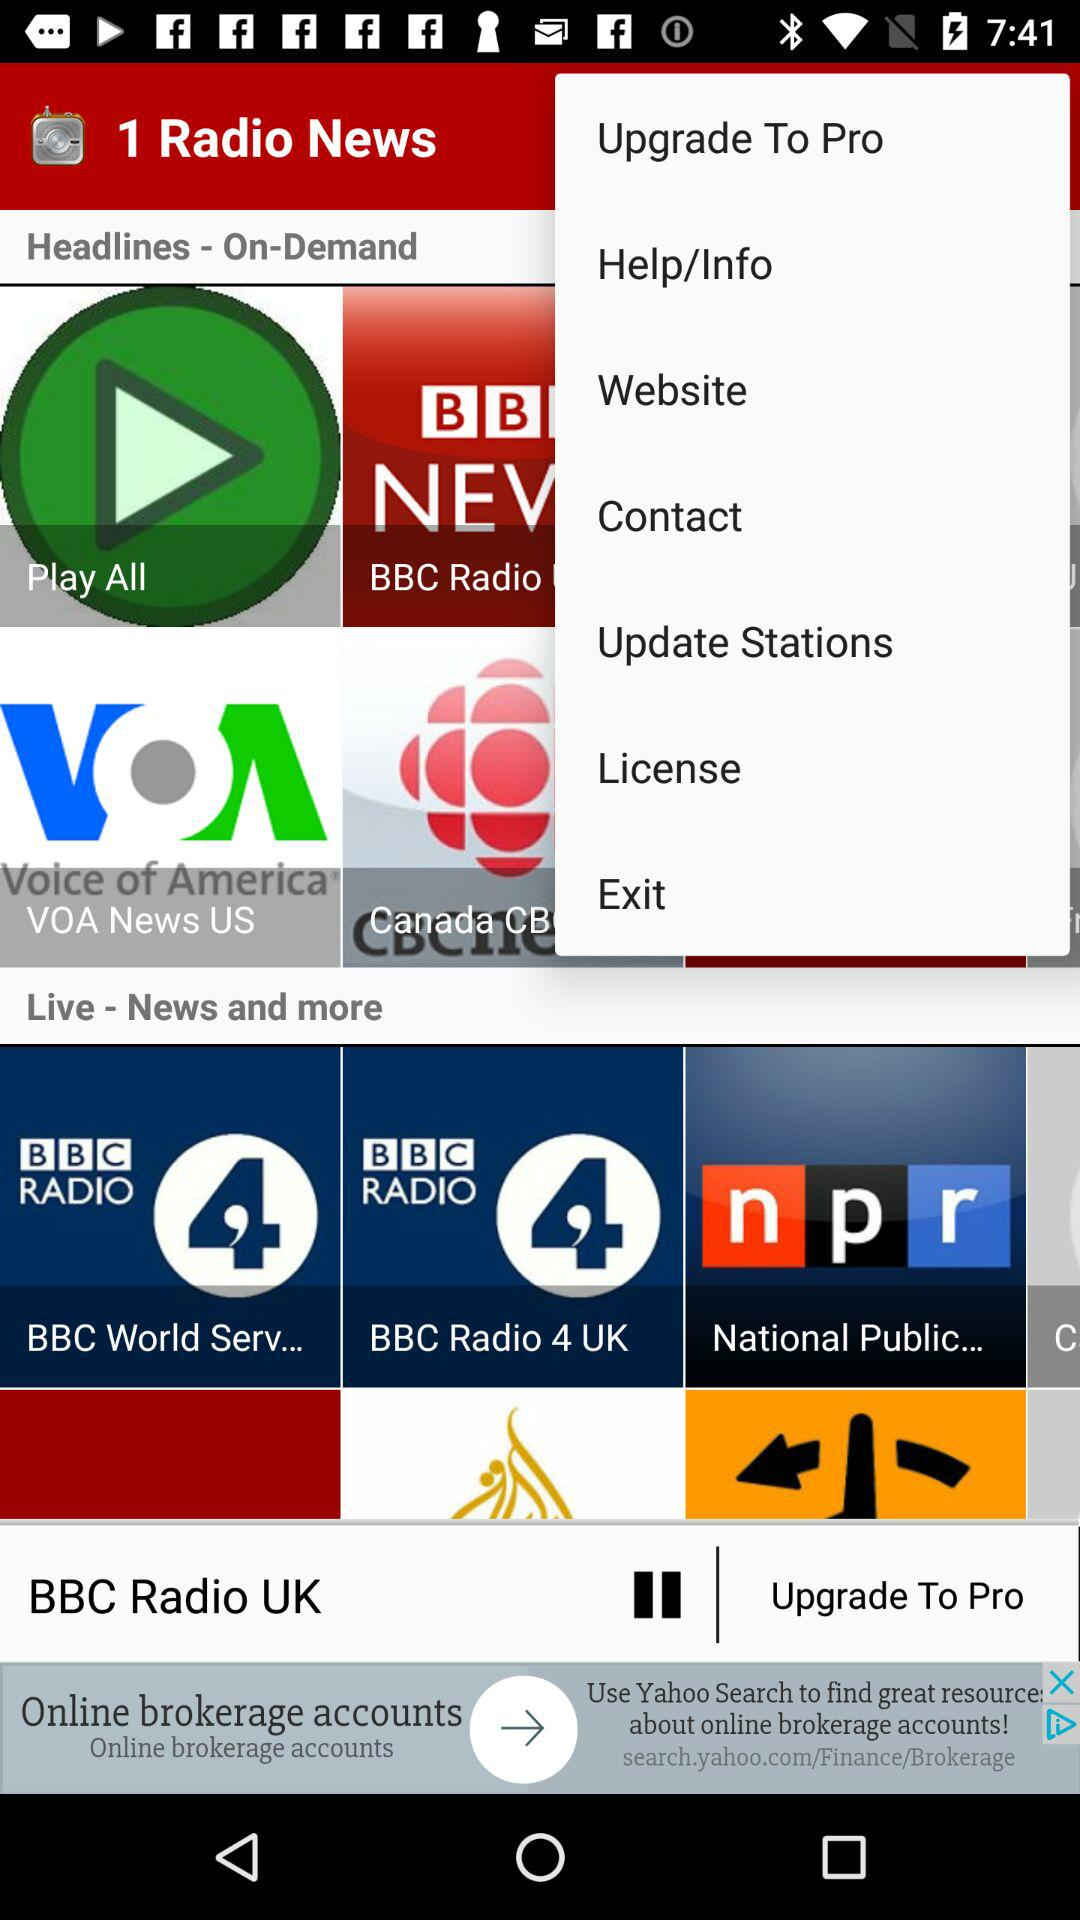Which radio is playing now? The radio that is playing now is "BBC Radio UK". 